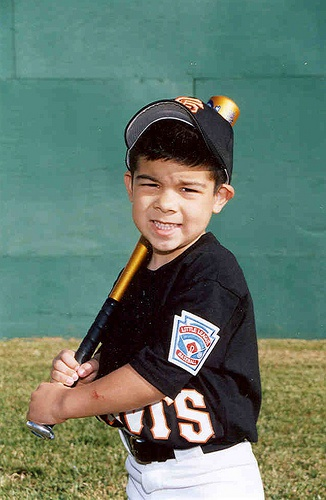Describe the objects in this image and their specific colors. I can see people in teal, black, white, salmon, and tan tones and baseball bat in teal, black, brown, orange, and maroon tones in this image. 